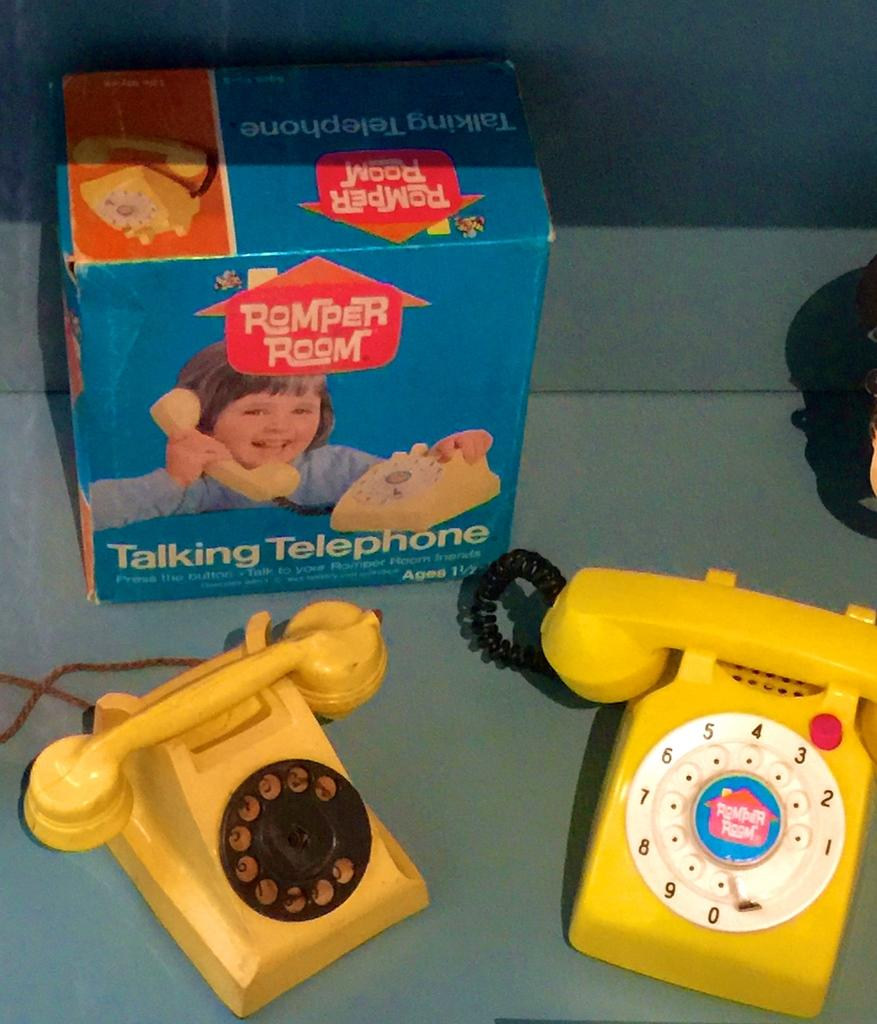<image>
Describe the image concisely. Two yellow roll phones next to their box behind them that says romper room. 